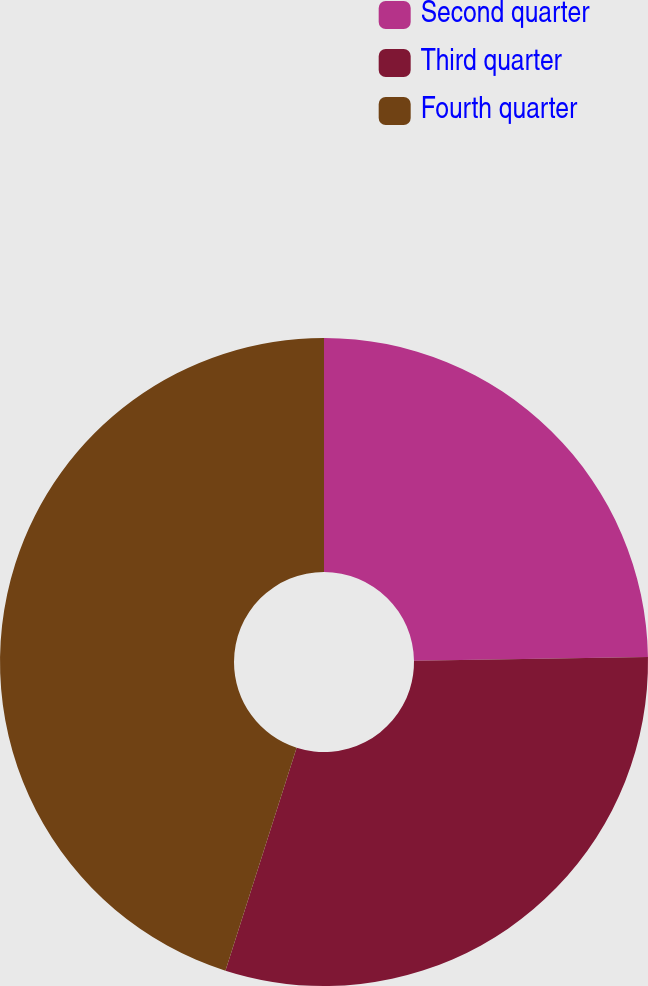<chart> <loc_0><loc_0><loc_500><loc_500><pie_chart><fcel>Second quarter<fcel>Third quarter<fcel>Fourth quarter<nl><fcel>24.76%<fcel>30.16%<fcel>45.08%<nl></chart> 